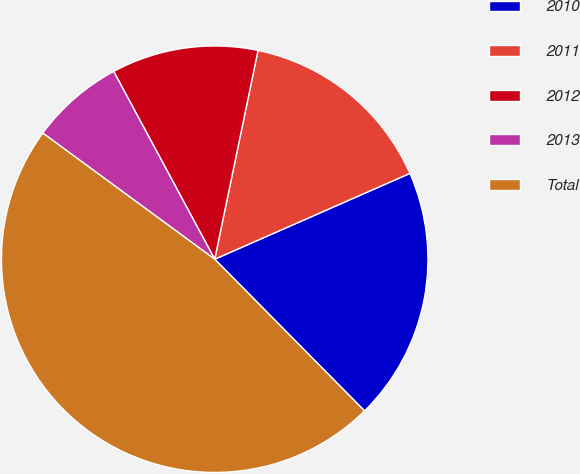Convert chart. <chart><loc_0><loc_0><loc_500><loc_500><pie_chart><fcel>2010<fcel>2011<fcel>2012<fcel>2013<fcel>Total<nl><fcel>19.19%<fcel>15.15%<fcel>11.11%<fcel>7.07%<fcel>47.47%<nl></chart> 